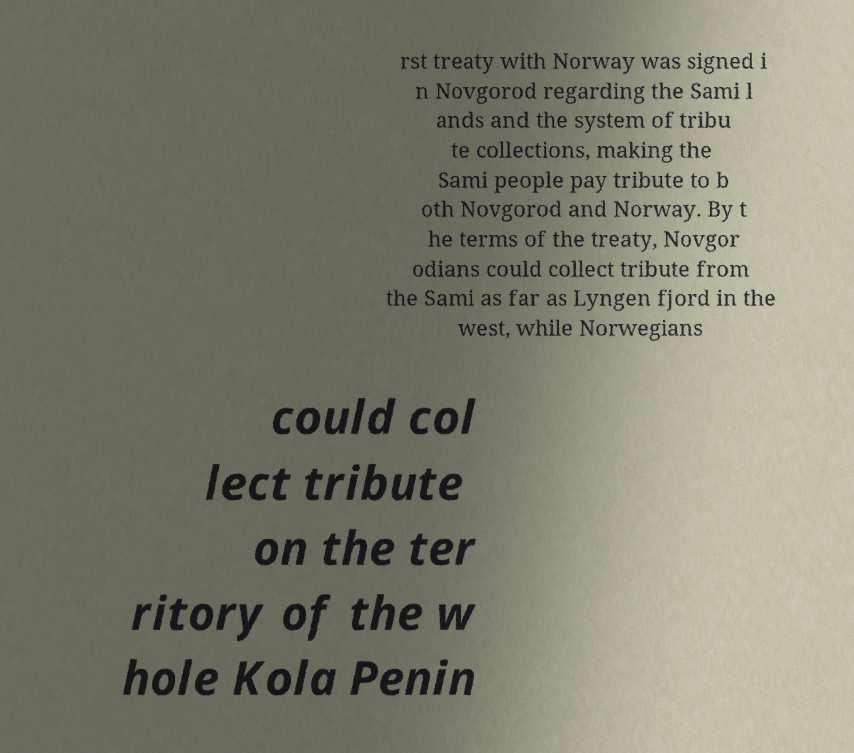For documentation purposes, I need the text within this image transcribed. Could you provide that? rst treaty with Norway was signed i n Novgorod regarding the Sami l ands and the system of tribu te collections, making the Sami people pay tribute to b oth Novgorod and Norway. By t he terms of the treaty, Novgor odians could collect tribute from the Sami as far as Lyngen fjord in the west, while Norwegians could col lect tribute on the ter ritory of the w hole Kola Penin 